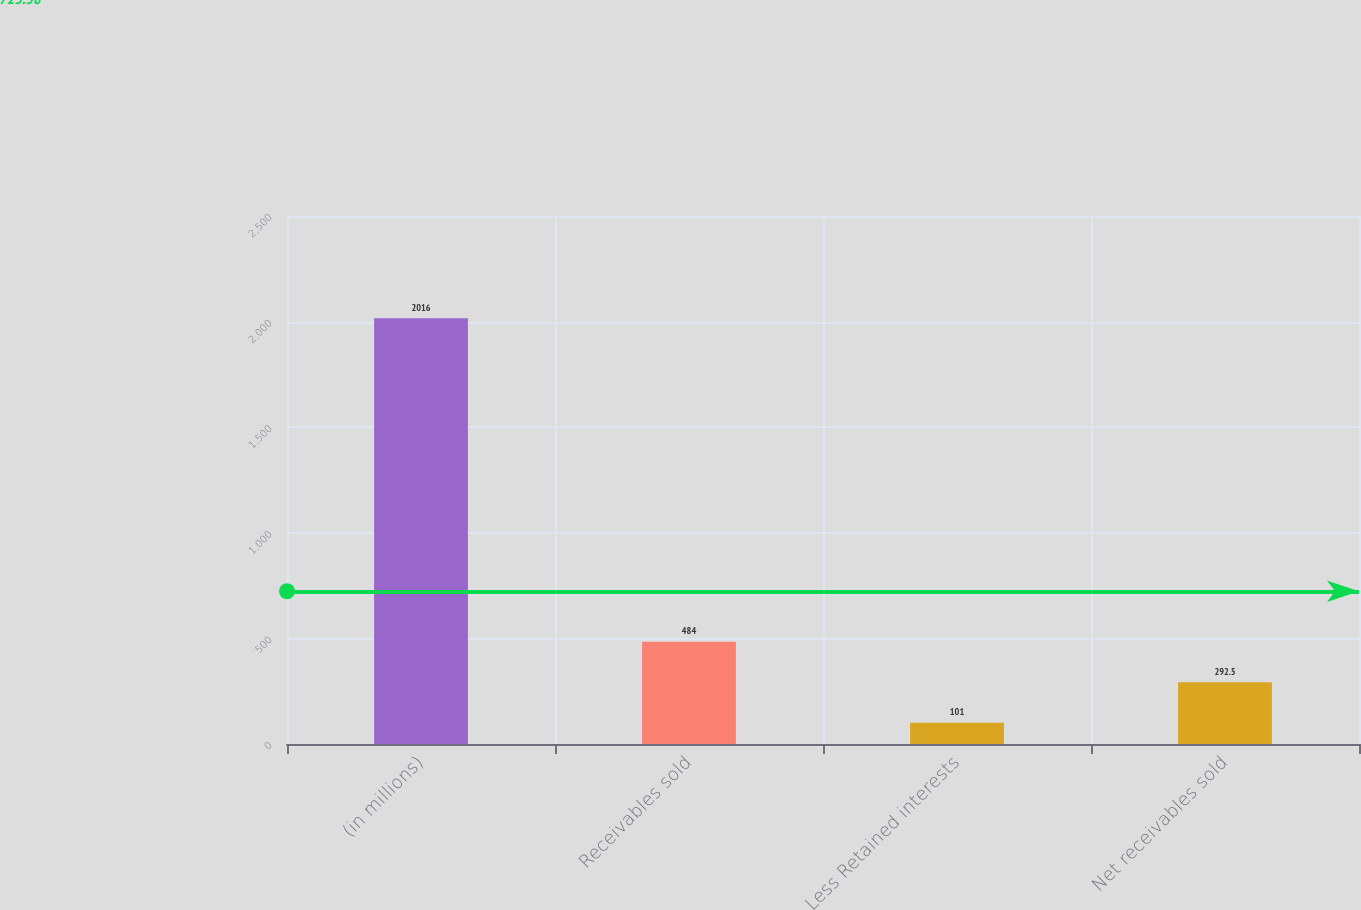Convert chart. <chart><loc_0><loc_0><loc_500><loc_500><bar_chart><fcel>(in millions)<fcel>Receivables sold<fcel>Less Retained interests<fcel>Net receivables sold<nl><fcel>2016<fcel>484<fcel>101<fcel>292.5<nl></chart> 